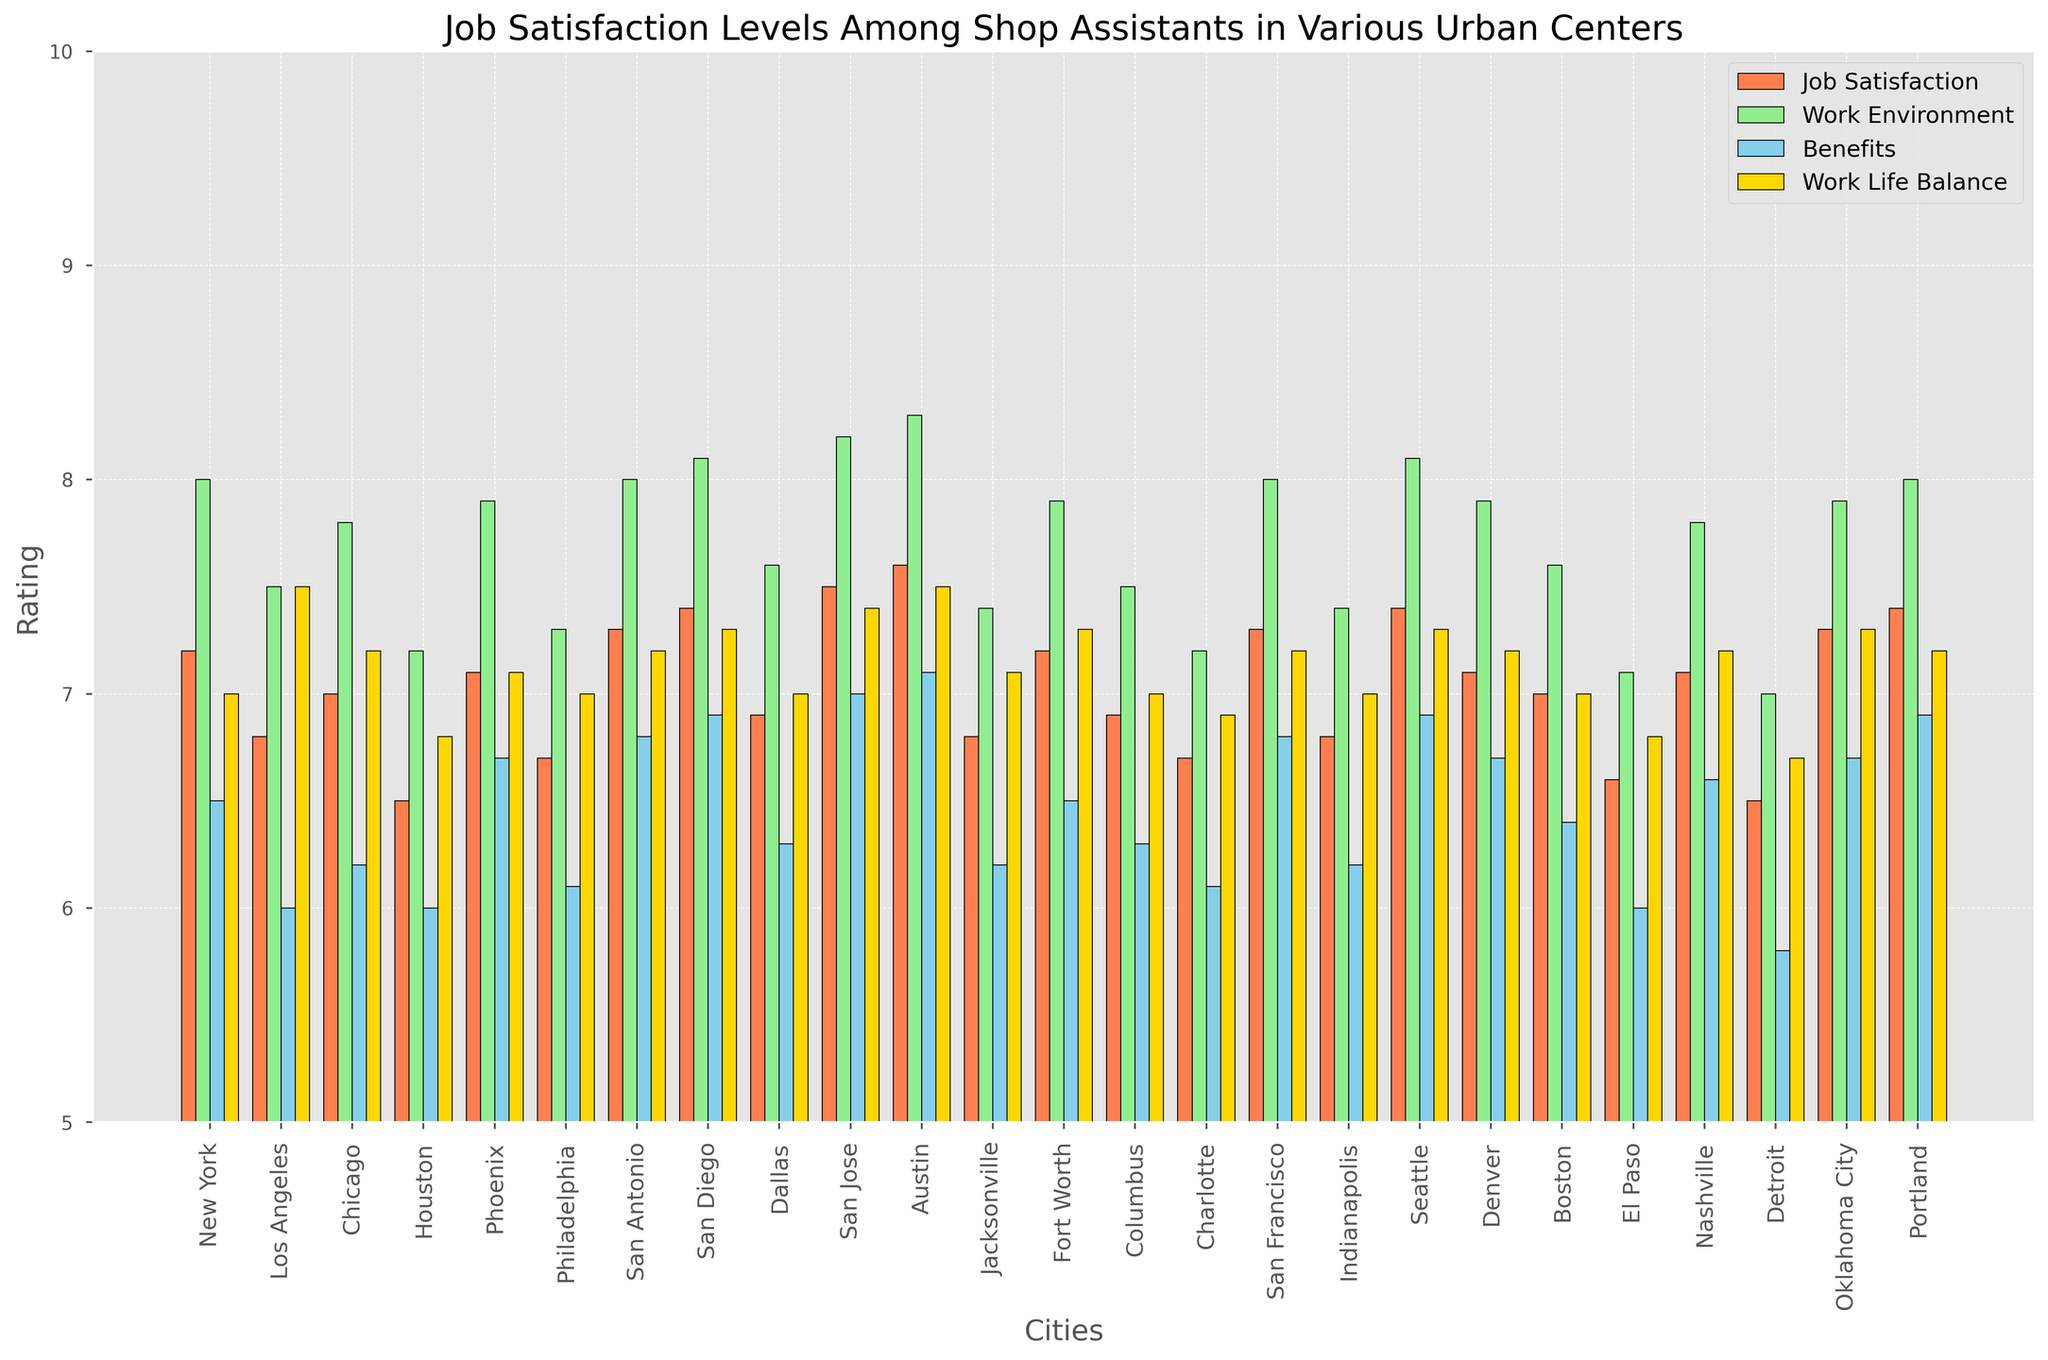Which city has the highest job satisfaction rating? Look for the bar labeled "Job Satisfaction" that reaches the highest point. Locate the corresponding city label on the x-axis.
Answer: Austin Which city has the lowest rating for benefits? Look for the shortest bar labeled "Benefits" and find the corresponding city label on the x-axis.
Answer: Detroit What is the job satisfaction rating in San Jose? Identify the bar representing San Jose for "Job Satisfaction" and note the value it reaches on the y-axis.
Answer: 7.5 Compare the work environment ratings between New York and Los Angeles. Which is higher? Compare the heights of the "Work Environment" bars for New York and Los Angeles. Determine which bar is taller.
Answer: New York What is the average work-life balance rating of Austin and San Diego? Locate the "Work Life Balance" bars for Austin and San Diego. Sum the two values (7.5 + 7.3) and divide by 2 to get the average.
Answer: 7.4 Which cities have a job satisfaction rating of 7 or higher? Identify all the bars labeled "Job Satisfaction" that reach or exceed the value of 7 and list their corresponding cities.
Answer: New York, Chicago, Phoenix, San Antonio, San Diego, San Jose, Austin, Fort Worth, San Francisco, Seattle, Denver, Nashville, Oklahoma City, Portland Which city has the most balanced ratings across job satisfaction, work environment, benefits, and work-life balance? Identify the city whose bars have the closest heights across all categories.
Answer: Austin How much higher is the job satisfaction rating in San Francisco compared to Houston? Find the difference in heights between the "Job Satisfaction" bars for San Francisco and Houston. Subtract Houston's value from San Francisco's value (7.3 - 6.5).
Answer: 0.8 What is the sum of all ratings (Job Satisfaction, Work Environment, Benefits, Work-Life Balance) for Phoenix? Sum the values of the four bars representing Phoenix: (7.1 + 7.9 + 6.7 + 7.1).
Answer: 28.8 